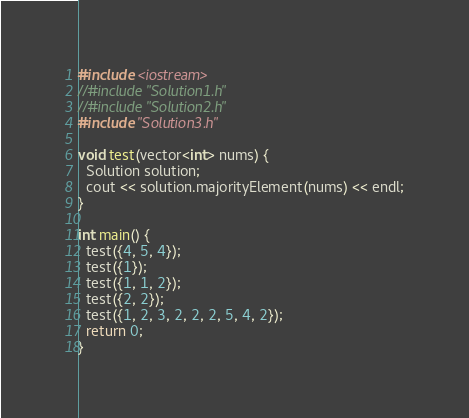<code> <loc_0><loc_0><loc_500><loc_500><_C++_>#include <iostream>
//#include "Solution1.h"
//#include "Solution2.h"
#include "Solution3.h"

void test(vector<int> nums) {
  Solution solution;
  cout << solution.majorityElement(nums) << endl;
}

int main() {
  test({4, 5, 4});
  test({1});
  test({1, 1, 2});
  test({2, 2});
  test({1, 2, 3, 2, 2, 2, 5, 4, 2});
  return 0;
}
</code> 